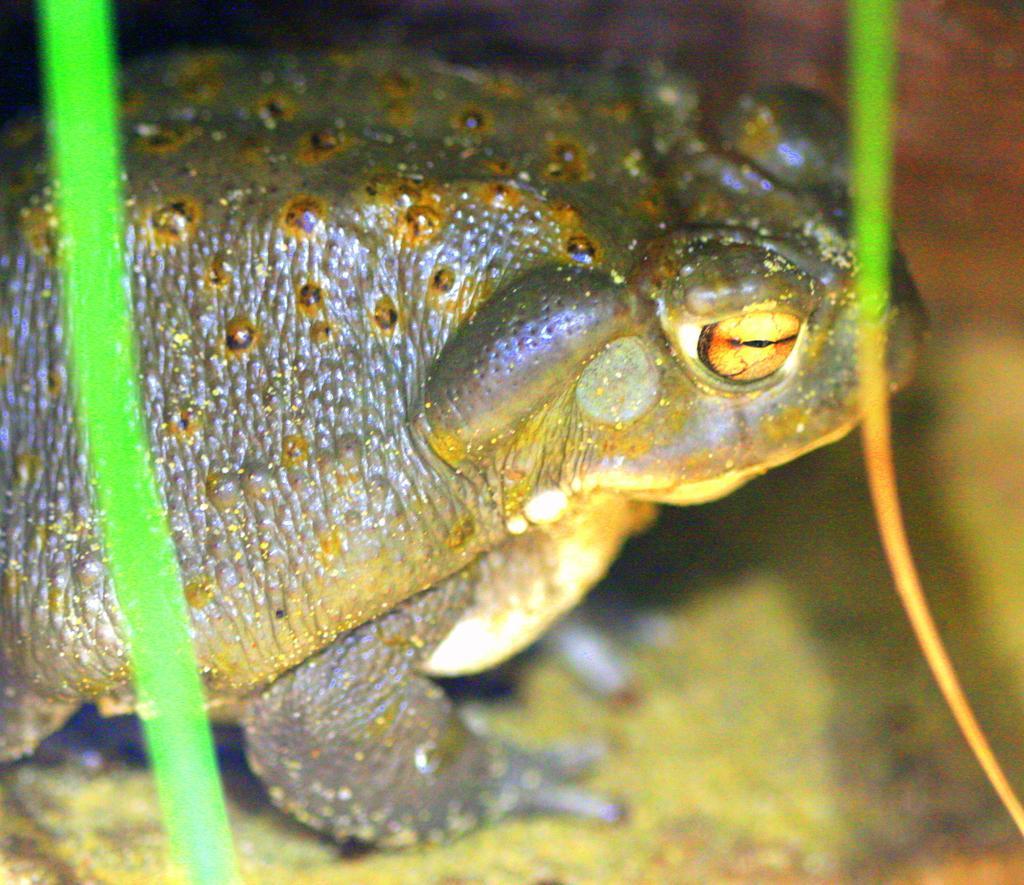Please provide a concise description of this image. In this image we can see a frog. 